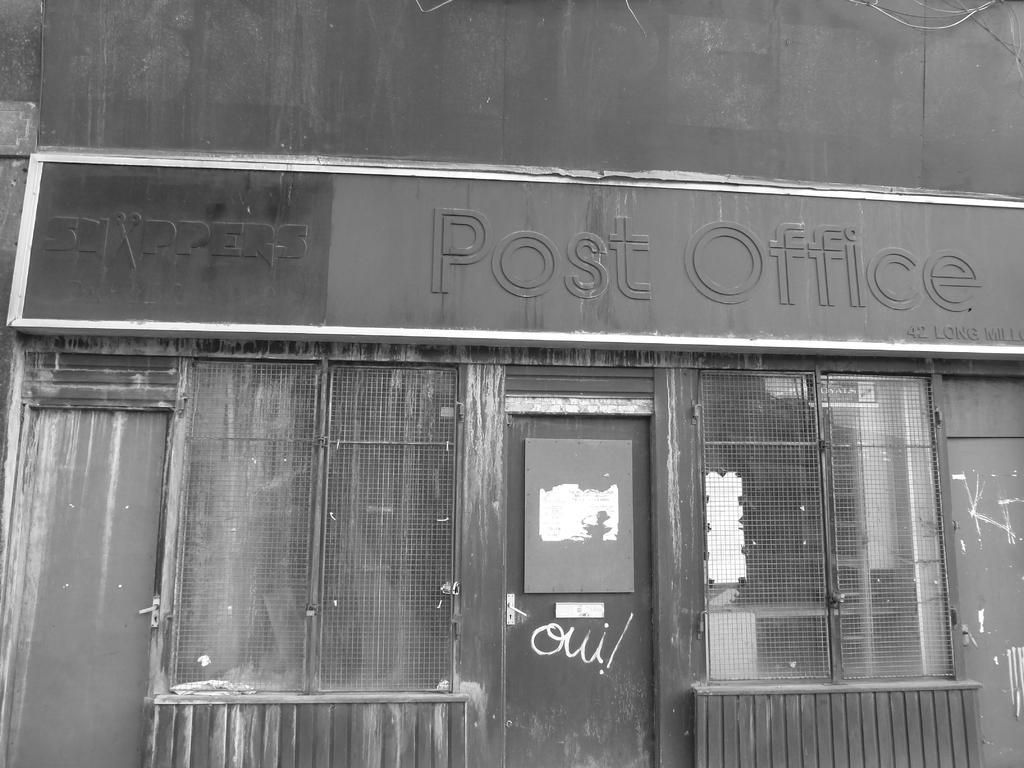In one or two sentences, can you explain what this image depicts? In this image we can see there is a board with some text on the wall of a building and there are doors and windows. 